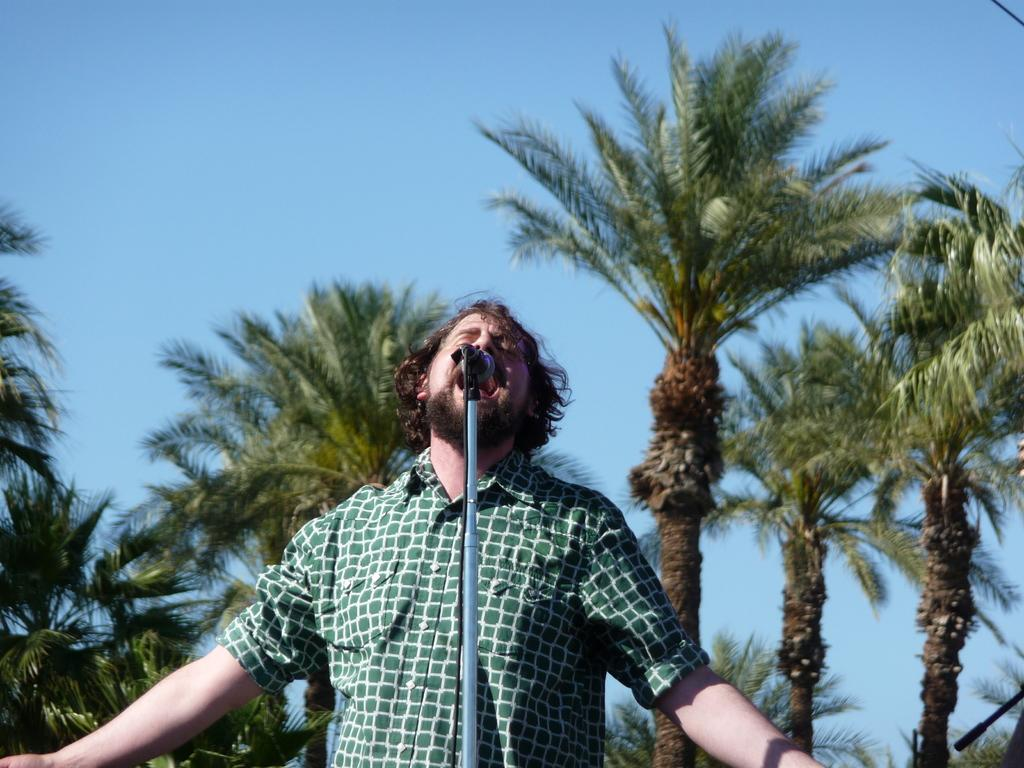What is the main subject of the image? There is a man in the image. What is the man wearing? The man is wearing a shirt. What is the man doing in the image? The man is singing a song. What is in front of the man? There is a microphone with a stand in front of the man. What is connected to the microphone? There is a cable associated with the microphone. What can be seen in the background of the image? There are trees and the sky visible in the background of the image. What type of apple is being served in the afternoon during the flight in the image? There is no flight, afternoon, or apple present in the image. The image features a man singing with a microphone and a shirt on, with trees and the sky visible in the background. 